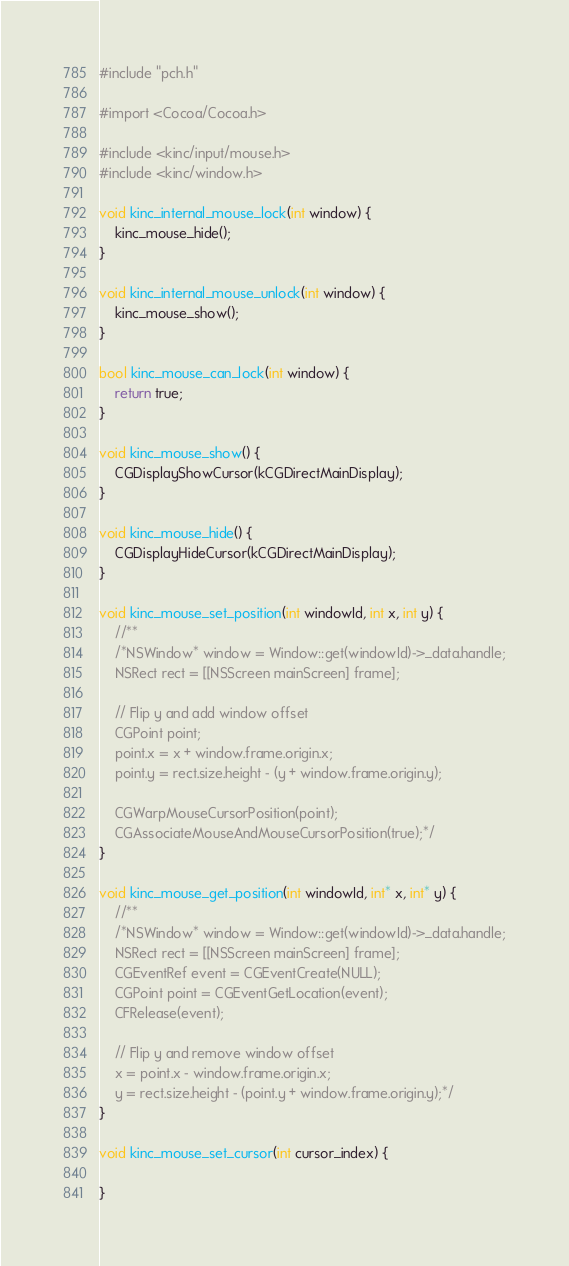Convert code to text. <code><loc_0><loc_0><loc_500><loc_500><_ObjectiveC_>#include "pch.h"

#import <Cocoa/Cocoa.h>

#include <kinc/input/mouse.h>
#include <kinc/window.h>

void kinc_internal_mouse_lock(int window) {
	kinc_mouse_hide();
}

void kinc_internal_mouse_unlock(int window) {
	kinc_mouse_show();
}

bool kinc_mouse_can_lock(int window) {
	return true;
}

void kinc_mouse_show() {
	CGDisplayShowCursor(kCGDirectMainDisplay);
}

void kinc_mouse_hide() {
	CGDisplayHideCursor(kCGDirectMainDisplay);
}

void kinc_mouse_set_position(int windowId, int x, int y) {
	//**
	/*NSWindow* window = Window::get(windowId)->_data.handle;
	NSRect rect = [[NSScreen mainScreen] frame];
	
	// Flip y and add window offset
	CGPoint point;
	point.x = x + window.frame.origin.x;
	point.y = rect.size.height - (y + window.frame.origin.y);
	
	CGWarpMouseCursorPosition(point);
	CGAssociateMouseAndMouseCursorPosition(true);*/
}

void kinc_mouse_get_position(int windowId, int* x, int* y) {
	//**
	/*NSWindow* window = Window::get(windowId)->_data.handle;
	NSRect rect = [[NSScreen mainScreen] frame];
	CGEventRef event = CGEventCreate(NULL);
	CGPoint point = CGEventGetLocation(event);
	CFRelease(event);

	// Flip y and remove window offset
	x = point.x - window.frame.origin.x;
	y = rect.size.height - (point.y + window.frame.origin.y);*/
}

void kinc_mouse_set_cursor(int cursor_index) {

}
</code> 